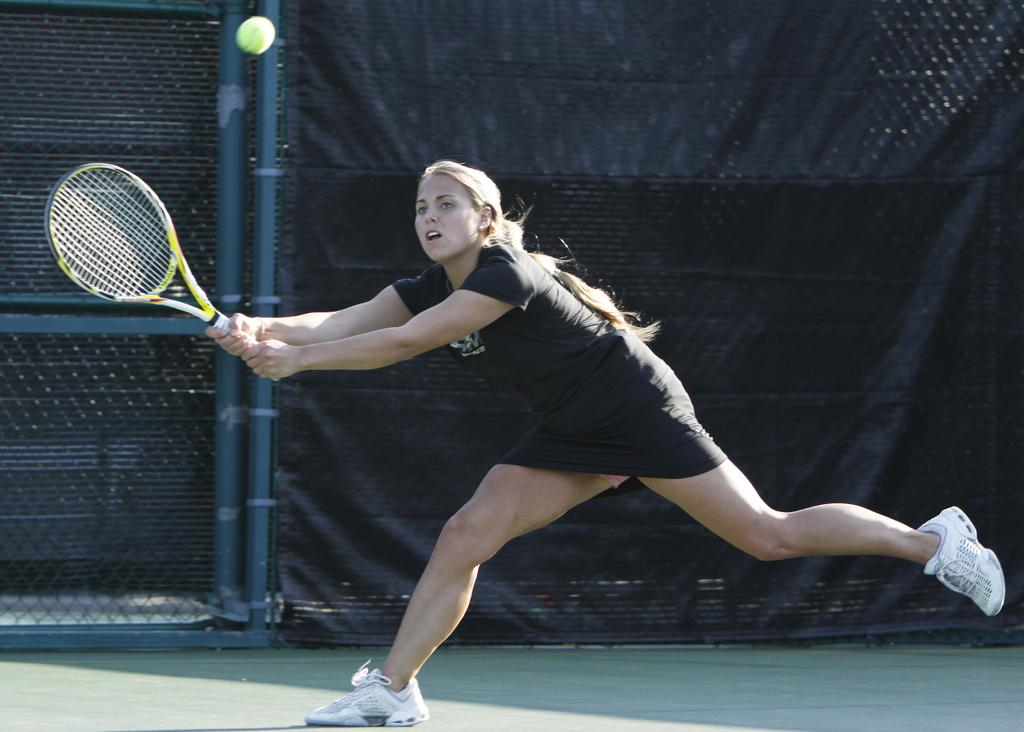Who is the main subject in the image? There is a lady in the image. What is the lady doing in the image? The lady is playing tennis. What can be seen in the background of the image? There is a black fence in the background of the image. How many zippers are visible on the lady's tennis outfit in the image? There is no mention of zippers on the lady's tennis outfit in the image, so we cannot determine the number of zippers. 